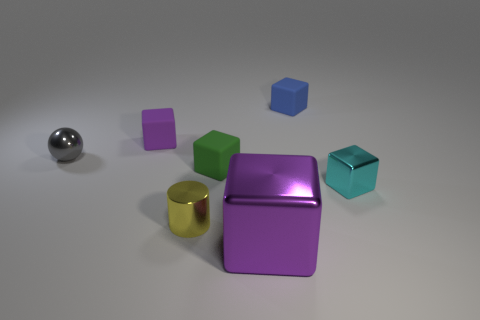What color is the big metal thing?
Provide a succinct answer. Purple. There is a cube that is in front of the cylinder in front of the object that is right of the blue rubber thing; what is its size?
Your answer should be compact. Large. How many other things are the same shape as the purple metal thing?
Provide a succinct answer. 4. There is a metal thing that is behind the shiny cylinder and to the right of the cylinder; what is its color?
Give a very brief answer. Cyan. Is there anything else that is the same size as the purple shiny cube?
Provide a succinct answer. No. Is the color of the rubber thing to the left of the tiny green cube the same as the large thing?
Provide a short and direct response. Yes. How many cubes are large purple things or blue rubber objects?
Keep it short and to the point. 2. The purple object that is in front of the gray shiny object has what shape?
Make the answer very short. Cube. There is a object behind the purple thing behind the small thing in front of the small cyan shiny cube; what is its color?
Your response must be concise. Blue. Is the material of the big block the same as the tiny yellow thing?
Provide a short and direct response. Yes. 